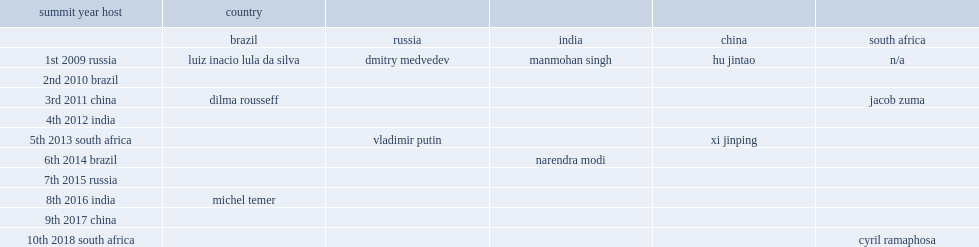List the five countries that the brics summit consists of. Brazil russia india china south africa. 